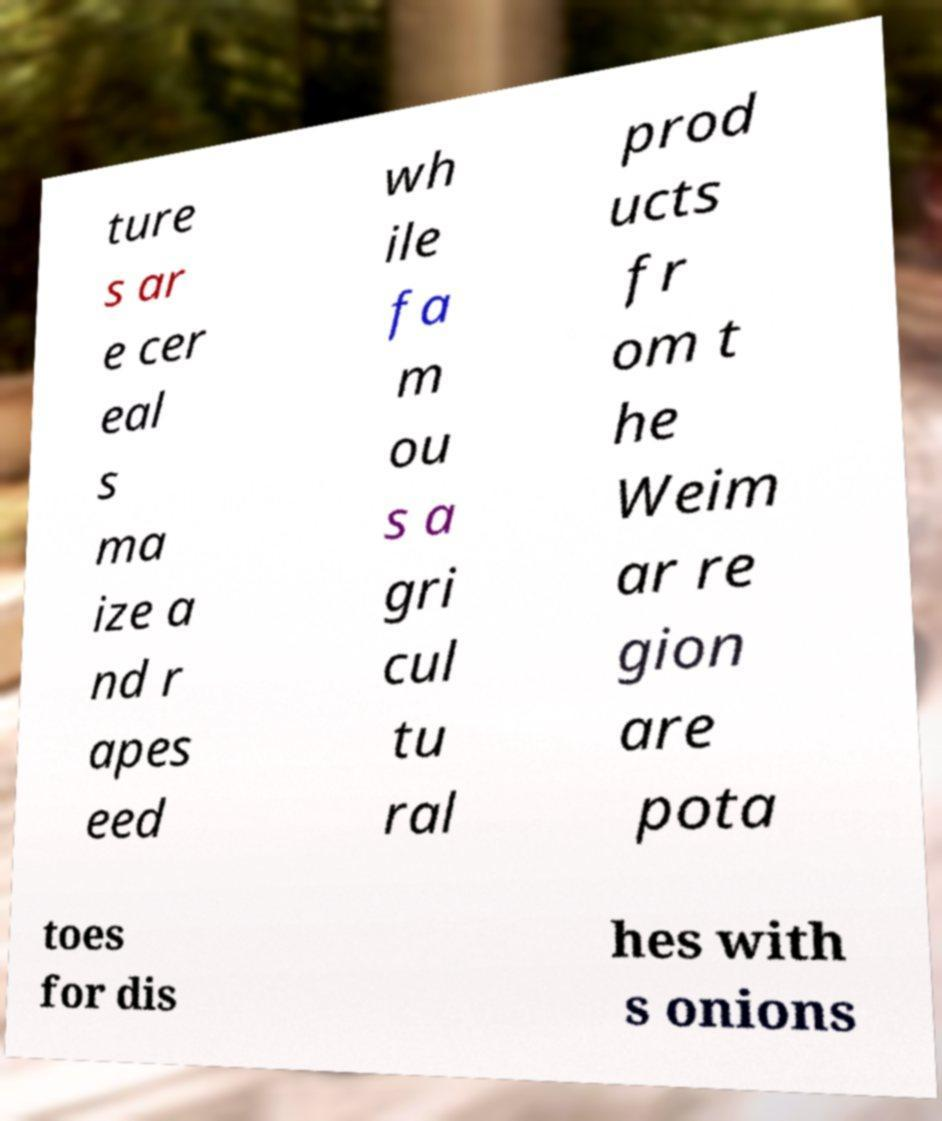For documentation purposes, I need the text within this image transcribed. Could you provide that? ture s ar e cer eal s ma ize a nd r apes eed wh ile fa m ou s a gri cul tu ral prod ucts fr om t he Weim ar re gion are pota toes for dis hes with s onions 